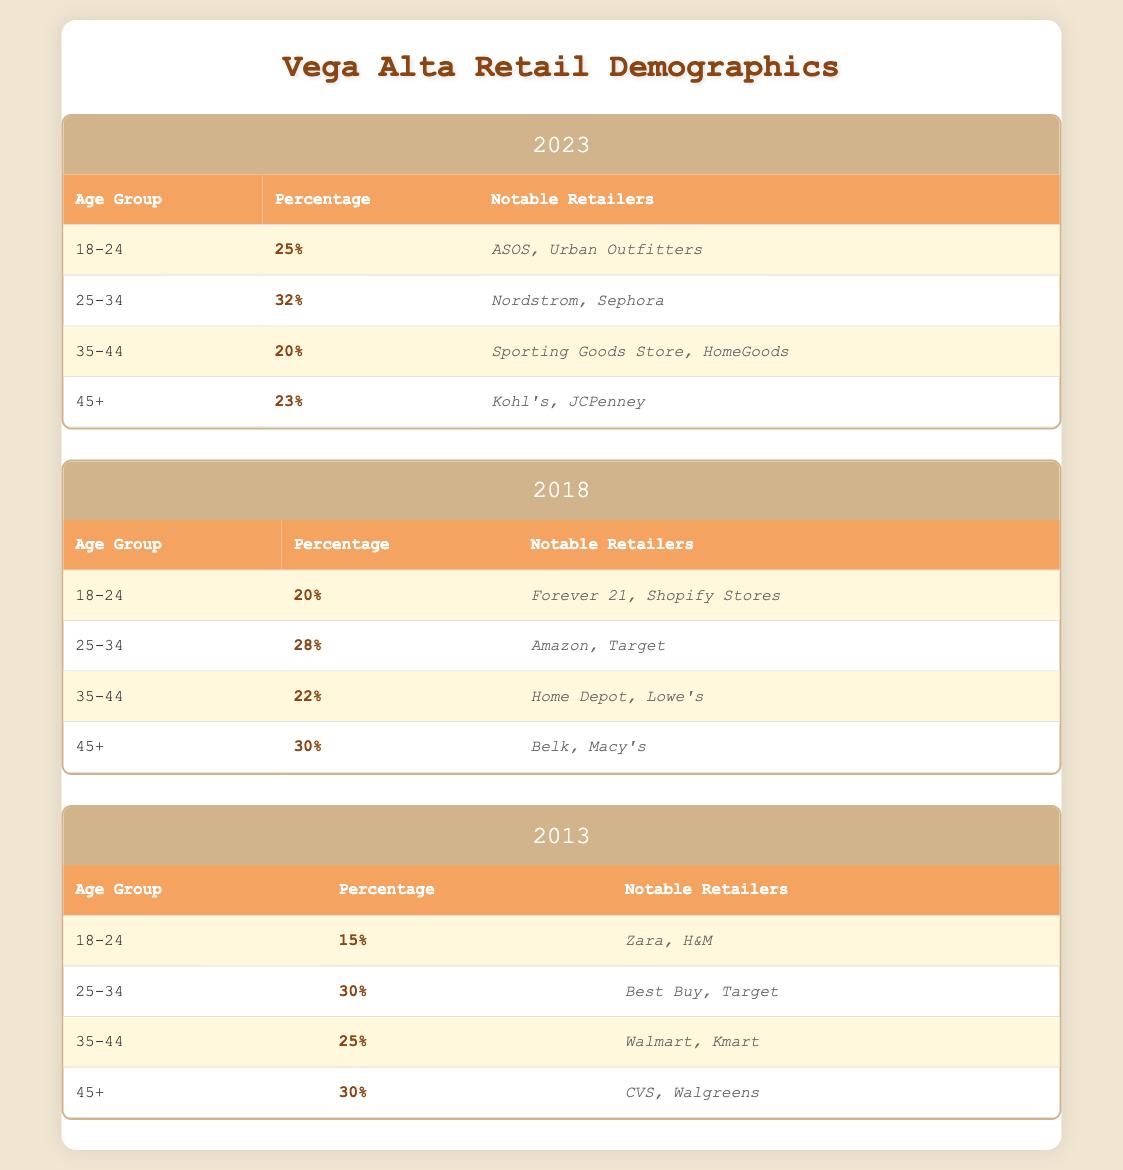What percentage of customers aged 18-24 were there in 2018? In 2018, the table shows that the percentage for the age group 18-24 is 20%.
Answer: 20% Which age group saw the highest percentage of customers in 2013? In 2013, the highest percentage was in the 25-34 age group at 30%.
Answer: 25-34 Did CVS appear as a notable retailer in 2023? According to the table, CVS is listed as a notable retailer only in 2013, not in 2023.
Answer: No What is the average percentage of customers aged 45+ across all three years? The percentages for 45+ in 2013, 2018, and 2023 are 30%, 30%, and 23%, respectively. The sum is 30 + 30 + 23 = 83, and the average is 83 / 3 = 27.67%.
Answer: 27.67% Which age group had the lowest representation in 2023? In 2023, the age group with the lowest percentage of customers is 35-44, which is 20%.
Answer: 35-44 Is there an increase in the percentage of the 18-24 age group from 2013 to 2023? Comparing 2013 (15%) and 2023 (25%), there is an increase of 10 percentage points in the 18-24 age group during that period.
Answer: Yes What notable retailers targeted customers aged 25-34 in 2018? For the age group 25-34 in 2018, the notable retailers are Amazon and Target.
Answer: Amazon, Target In which year did the 35-44 age group have the lowest percentage of customers? Analyzing the data, the 35-44 age group had the lowest percentage in 2023 at 20%.
Answer: 2023 What was the total percentage of all age groups combined in 2018? The total percentage for all age groups should equal 100%, as this is how the demographic percentages are usually calculated. Hence, the total is 100%.
Answer: 100% 